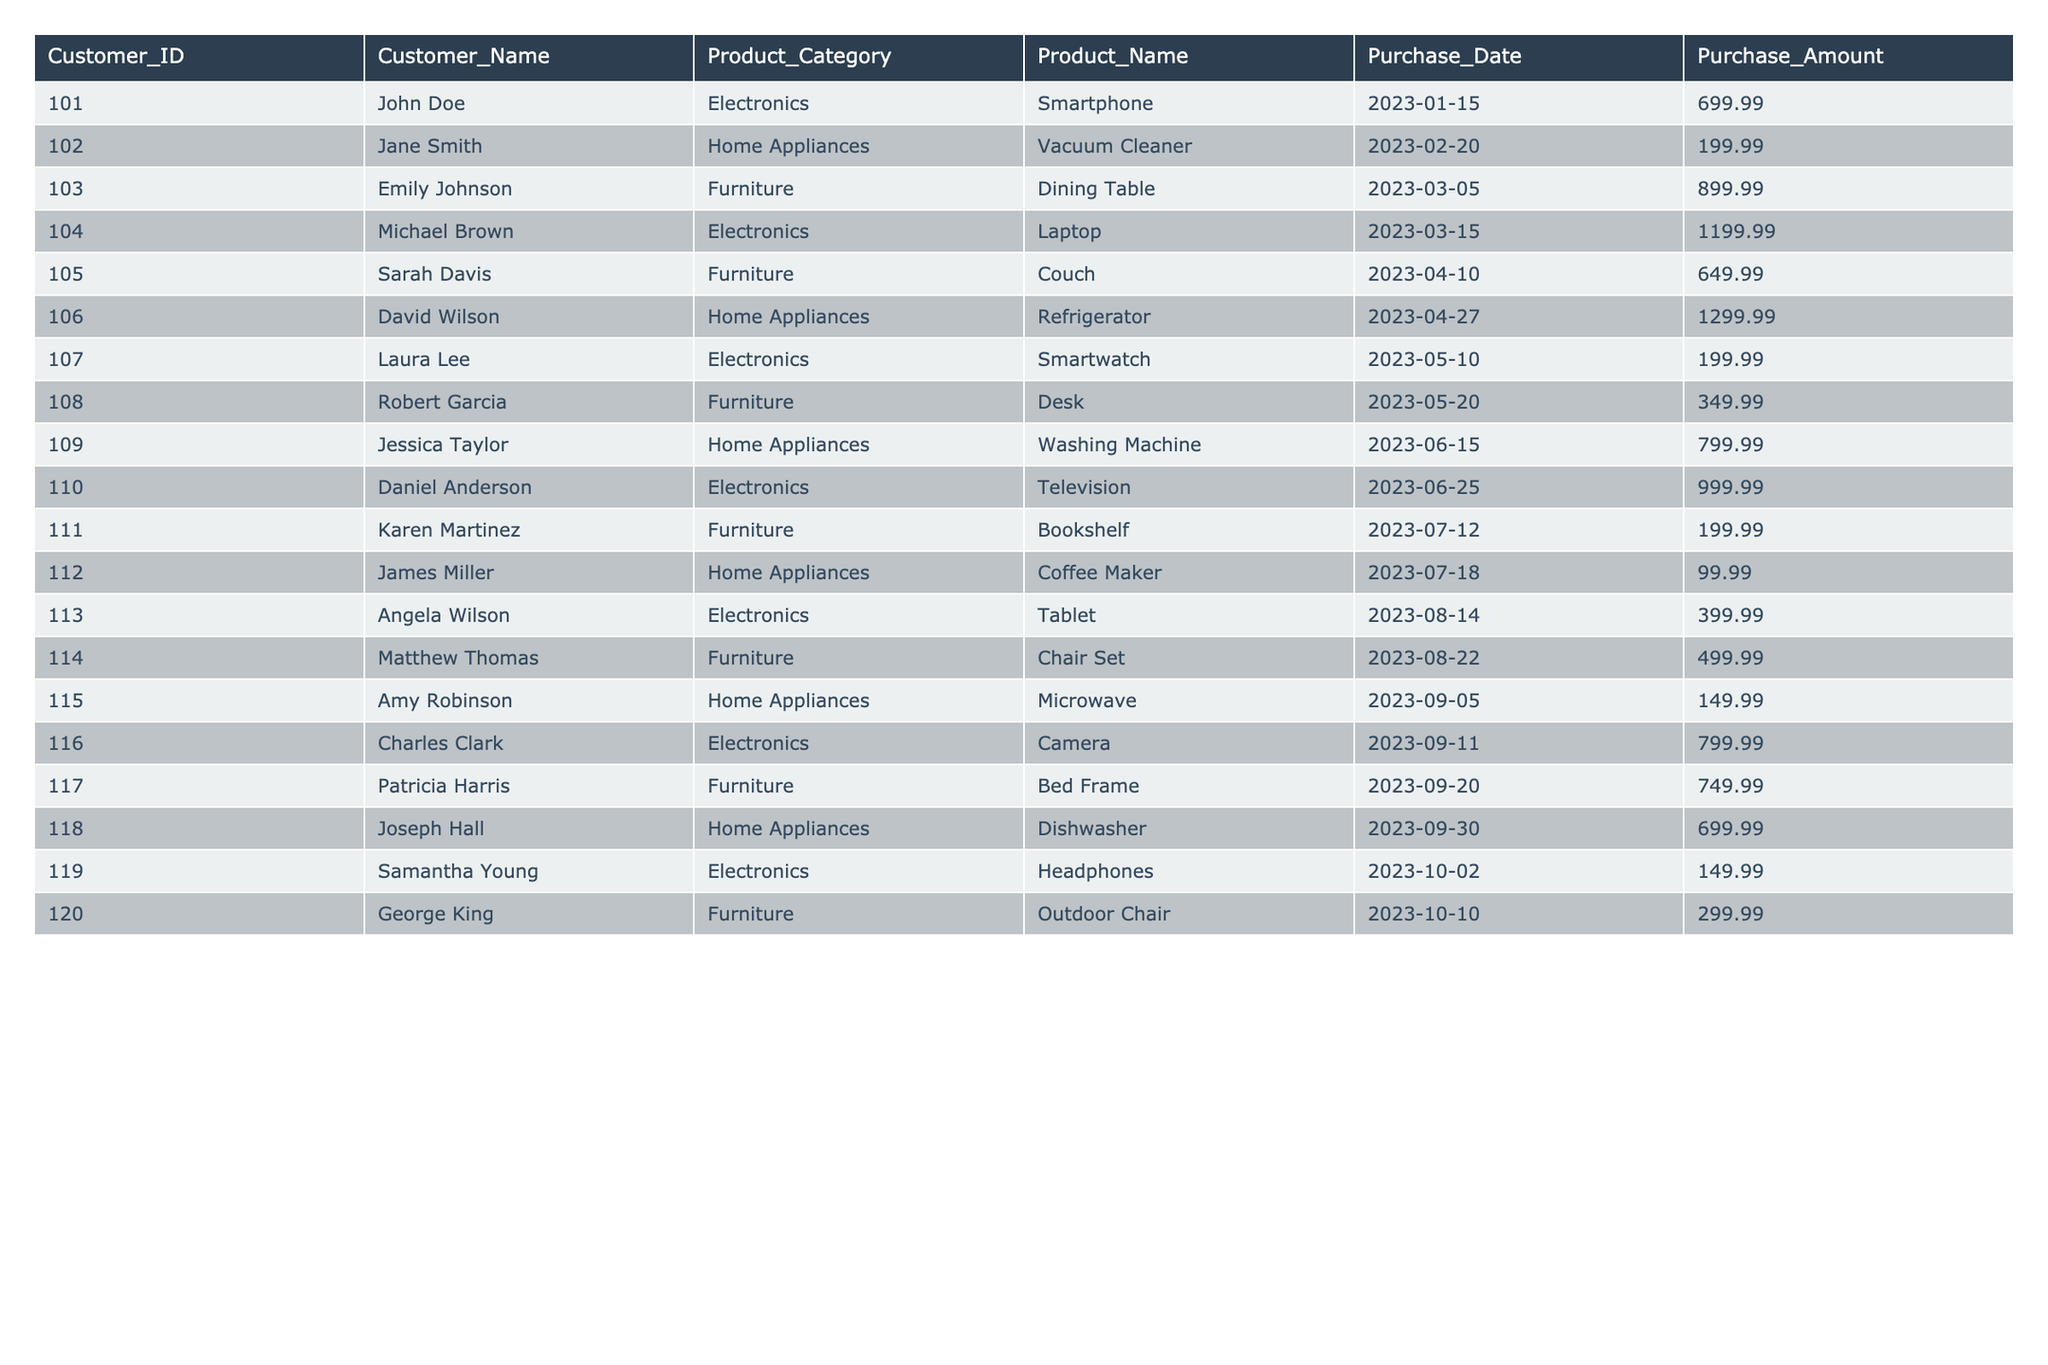What is the total purchase amount for all customers? Add all the purchase amounts from the "Purchase_Amount" column. The sum is: 699.99 + 199.99 + 899.99 + 1199.99 + 649.99 + 1299.99 + 199.99 + 349.99 + 799.99 + 999.99 + 199.99 + 99.99 + 399.99 + 499.99 + 149.99 + 799.99 + 749.99 + 699.99 + 149.99 + 299.99 = 11,949.7
Answer: 11,949.7 Which product category has the highest total purchase amount? Calculate the total purchase amount for each product category: Electronics (699.99 + 1199.99 + 199.99 + 999.99 + 399.99 + 799.99 + 149.99 = 4,148.94), Home Appliances (199.99 + 1299.99 + 799.99 + 99.99 + 149.99 + 699.99 = 3,249.94), and Furniture (899.99 + 649.99 + 349.99 + 199.99 + 499.99 + 749.99 + 299.99 = 3,649.93). Electronics has the highest total at 4,148.94
Answer: Electronics How many customers purchased furniture? Count the number of unique Customer_IDs associated with the Furniture category. The customers are 103, 105, 108, 111, 114, 117, and 120, totaling 7 customers.
Answer: 7 Did any customer purchase an Electronics product on the same date as a Furniture product? Review the purchase dates for each category. The dates for Electronics and Furniture do not overlap; therefore, no customer made purchases on the same date for both categories.
Answer: No What is the average purchase amount for Home Appliances? Sum the purchase amounts for Home Appliances (199.99 + 1299.99 + 799.99 + 99.99 + 149.99 + 699.99 = 3,249.94) and divide by the number of purchases (6). The average purchase amount is 3,249.94 / 6 = 541.66.
Answer: 541.66 Which customer spent the most and what was the purchase amount? Identify the maximum value in the "Purchase_Amount" column. The maximum value is 1,299.99 from David Wilson for purchasing a Refrigerator.
Answer: David Wilson, 1,299.99 What percentage of total purchases were made on electronics products? Total electronics purchases are 4,148.94. The percentage is (4,148.94 / 11,949.7) * 100 = 34.7%.
Answer: 34.7% What is the difference in total purchase amounts between Furniture and Home Appliances? Calculate the total for each: Furniture = 3,649.93, Home Appliances = 3,249.94. The difference is 3,649.93 - 3,249.94 = 399.99.
Answer: 399.99 